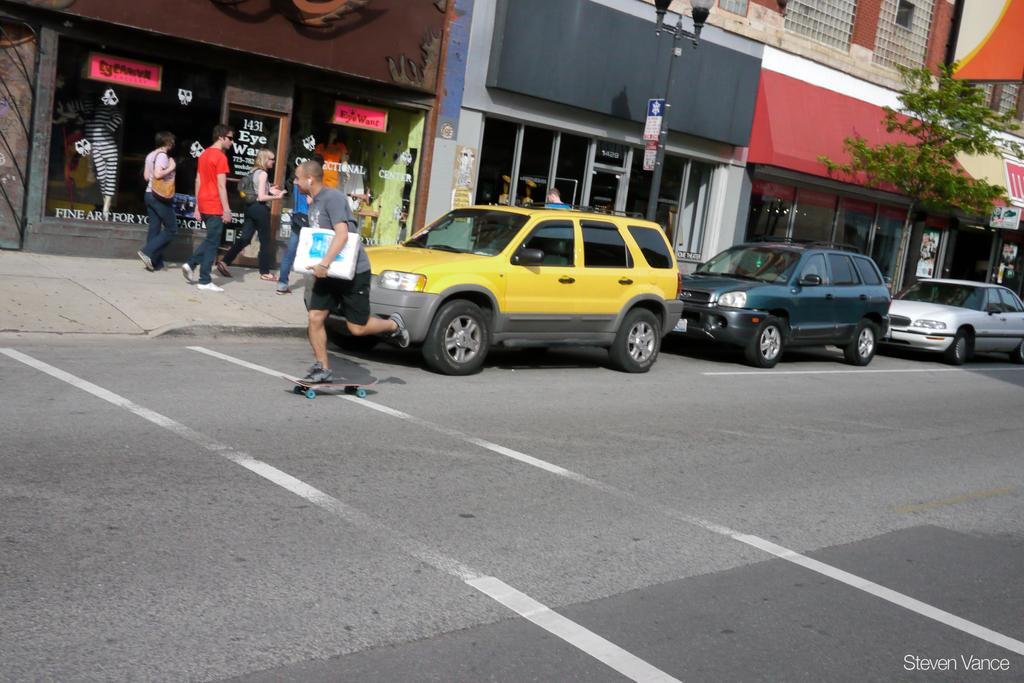What type of vehicles can be seen on the road in the image? There are cars on the road in the image. Can you describe the people in the image? There are people in the image, but their specific actions or appearances are not mentioned in the facts. What can be seen in the background of the image? There are buildings and boards in the background of the image. What type of natural element is present in the image? There is a tree in the image. What type of voice can be heard coming from the tree in the image? There is no voice coming from the tree in the image, as trees do not produce sounds. What type of string is attached to the cars in the image? There is no string attached to the cars in the image; they are on the road and not connected to any string. 